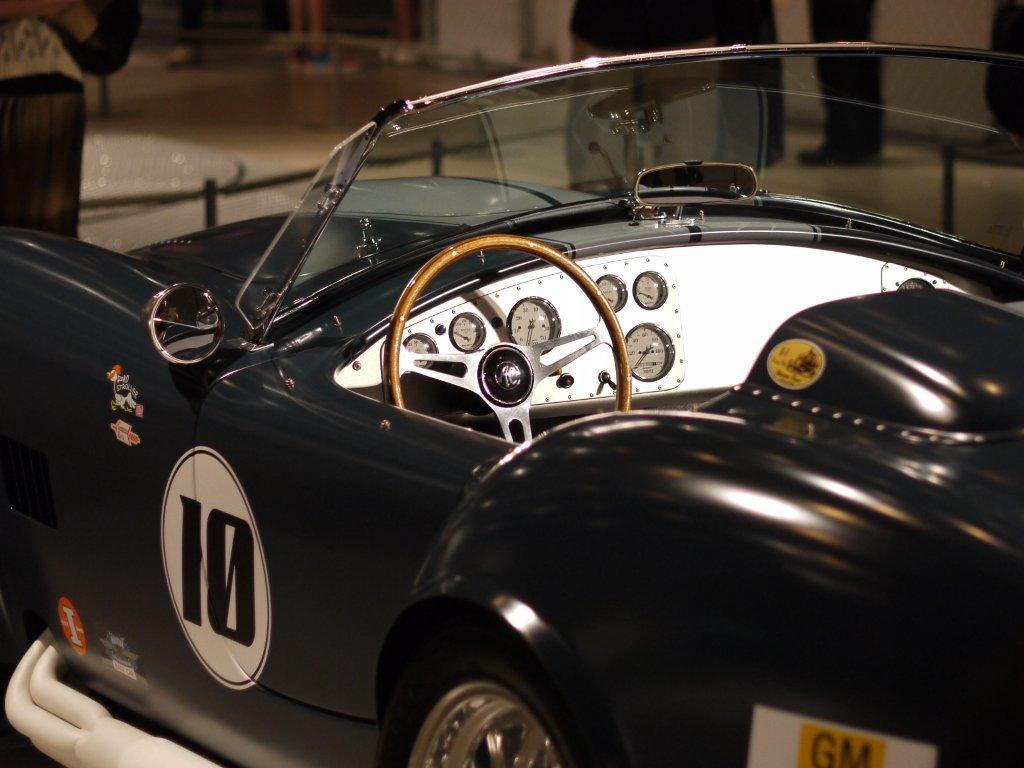What is the main subject in the center of the image? There is a car in the center of the image. What part of the image is visible at the top? The floor and a wall are visible at the top of the image. Are there any people in the image? Yes, there are people standing at the top of the image. How many lizards can be seen crawling on the car in the image? There are no lizards present in the image. What is the best way to reach the top of the wall in the image? The image does not provide information on how to reach the top of the wall, as it is a static representation. 